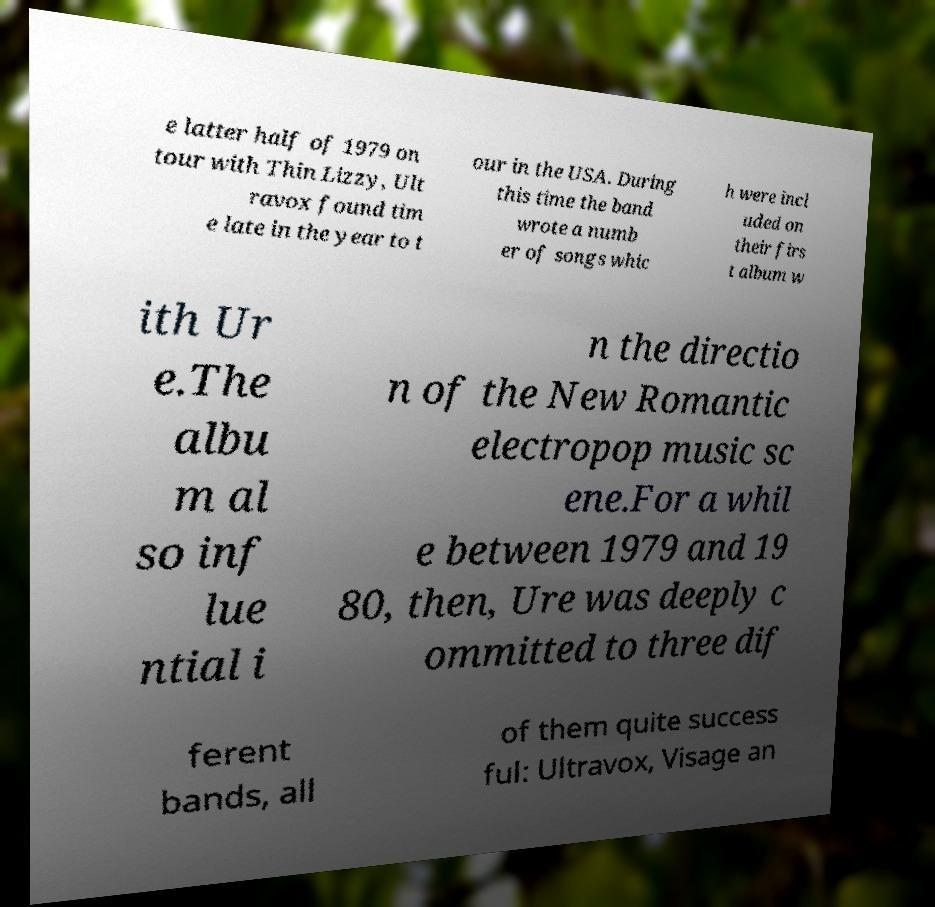Could you extract and type out the text from this image? e latter half of 1979 on tour with Thin Lizzy, Ult ravox found tim e late in the year to t our in the USA. During this time the band wrote a numb er of songs whic h were incl uded on their firs t album w ith Ur e.The albu m al so inf lue ntial i n the directio n of the New Romantic electropop music sc ene.For a whil e between 1979 and 19 80, then, Ure was deeply c ommitted to three dif ferent bands, all of them quite success ful: Ultravox, Visage an 